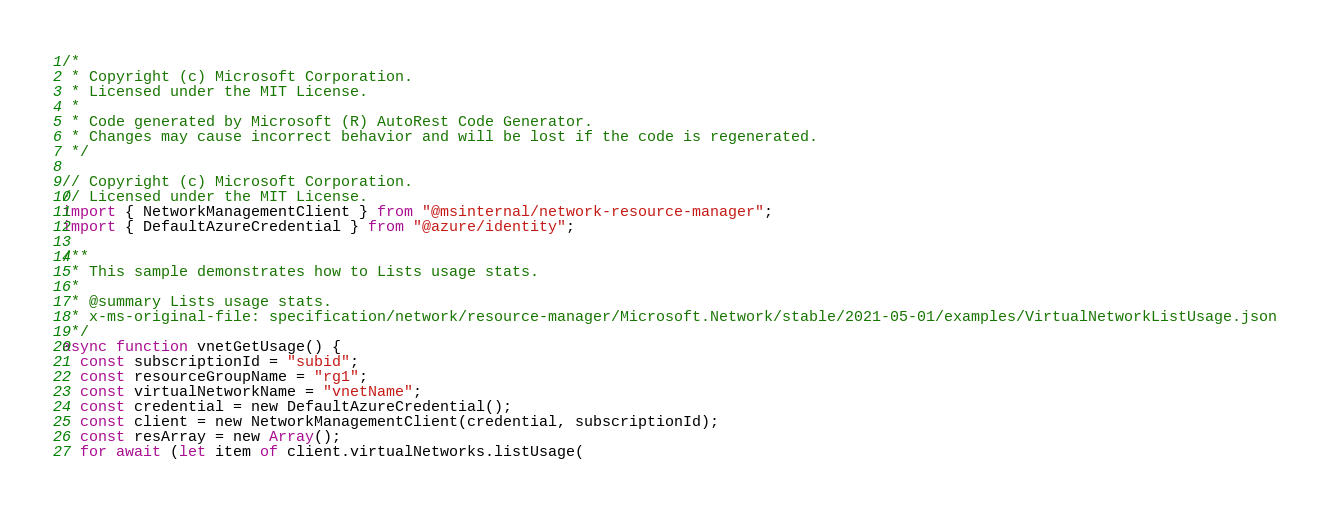Convert code to text. <code><loc_0><loc_0><loc_500><loc_500><_TypeScript_>/*
 * Copyright (c) Microsoft Corporation.
 * Licensed under the MIT License.
 *
 * Code generated by Microsoft (R) AutoRest Code Generator.
 * Changes may cause incorrect behavior and will be lost if the code is regenerated.
 */

// Copyright (c) Microsoft Corporation.
// Licensed under the MIT License.
import { NetworkManagementClient } from "@msinternal/network-resource-manager";
import { DefaultAzureCredential } from "@azure/identity";

/**
 * This sample demonstrates how to Lists usage stats.
 *
 * @summary Lists usage stats.
 * x-ms-original-file: specification/network/resource-manager/Microsoft.Network/stable/2021-05-01/examples/VirtualNetworkListUsage.json
 */
async function vnetGetUsage() {
  const subscriptionId = "subid";
  const resourceGroupName = "rg1";
  const virtualNetworkName = "vnetName";
  const credential = new DefaultAzureCredential();
  const client = new NetworkManagementClient(credential, subscriptionId);
  const resArray = new Array();
  for await (let item of client.virtualNetworks.listUsage(</code> 